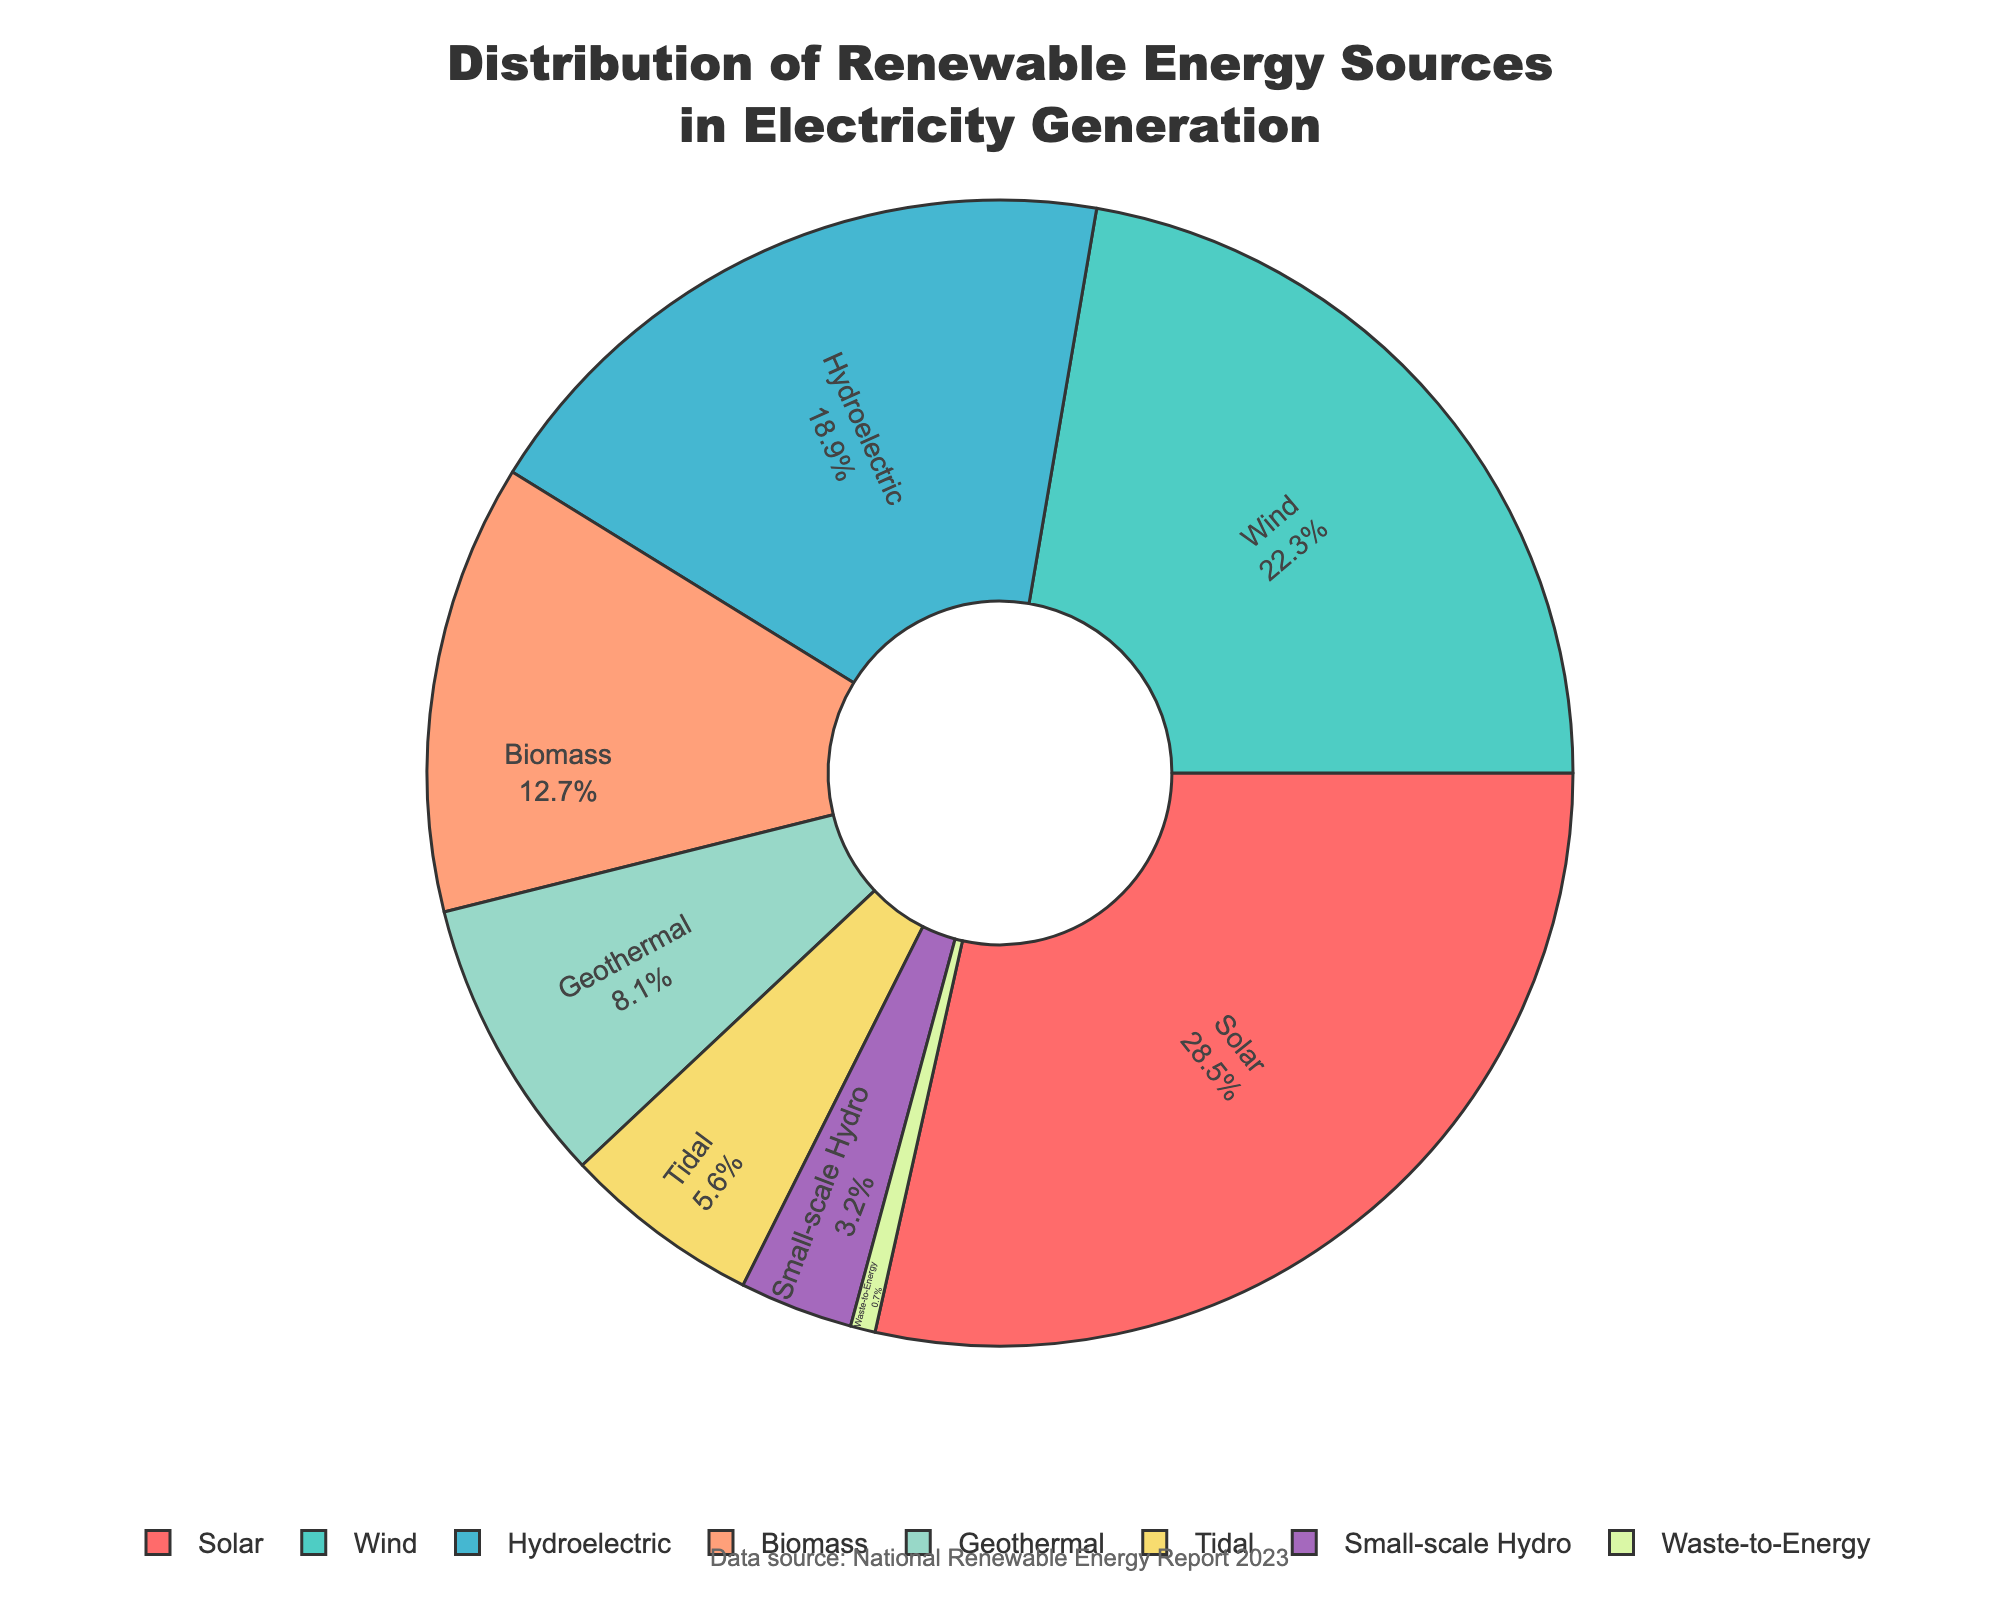what percentage of the electricity generation comes from solar energy? The pie chart shows the percentage values inside each segment. Locate the segment labeled "Solar" and read the percentage value.
Answer: 28.5% which renewable energy source has the smallest contribution? Identify the segment with the smallest percentage value in the chart. The smallest value is 0.7%, which corresponds to "Waste-to-Energy".
Answer: Waste-to-Energy what is the combined percentage of wind and hydroelectric energy? Locate the segments for "Wind" and "Hydroelectric". Add their percentage values: 22.3% (Wind) + 18.9% (Hydroelectric) = 41.2%.
Answer: 41.2% how many renewable energy sources contribute more than 10% each to the electricity generation? Count the segments where the percentage values are greater than 10%. These segments are "Solar" (28.5%), "Wind" (22.3%), "Hydroelectric" (18.9%), and "Biomass" (12.7%), totaling four sources.
Answer: 4 which energy source contributes nearly the same as geothermal and waste-to-energy combined? Locate the segments for "Geothermal" and "Waste-to-Energy". Add their percentage values: 8.1% (Geothermal) + 0.7% (Waste-to-Energy) = 8.8%. The segment with a percentage closest to 8.8% is "Tidal" at 5.6%
Answer: Tidal what is the difference in percentage contribution between solar energy and biomass? Locate the segments for “Solar” and “Biomass”. Substract their percentage values: 28.5% (Solar) - 12.7% (Biomass) = 15.8%
Answer: 15.8% which energy source is visually represented by the green segment? Identify the energy source associated with the green color in the pie chart. This corresponds to the "Wind" segment, which is colored green.
Answer: Wind if the goal is to reach at least 50% of electricity generation from wind and solar together, how much more is needed to be achieved based on the current distribution? Add the current percentages of "Solar" and "Wind": 28.5% (Solar) + 22.3% (Wind) = 50.8%. Since the current sum is already 50.8%, the goal is achieved.
Answer: 0% which energy source has a contribution level closest to 20%? Locate the segment that has a percentage value closest to 20%. The segment for "Wind" has a value of 22.3%, which is closest to 20%.
Answer: Wind 